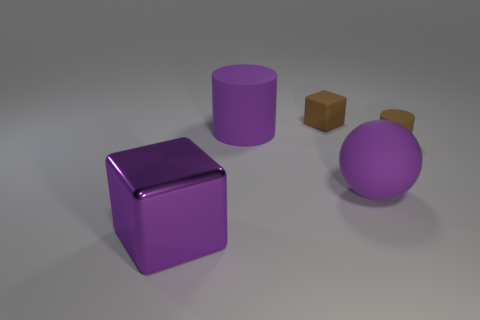If these objects were part of a game, what kind of game do you think it would be? If these objects were part of a game, it might be a puzzle or strategy game where players must manipulate or fit the shapes together in a specific order or configuration, perhaps using their distinctive colors and sizes as clues to solve the level. 